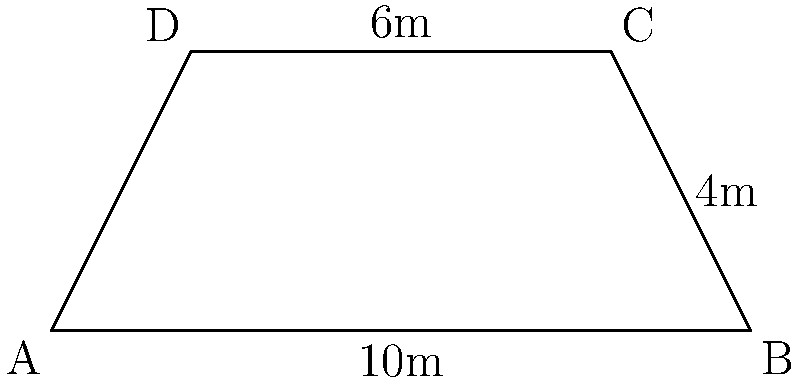Yo, check out this fancy-pants swimming pool at some billionaire's luxury resort! It's shaped like a trapezoid because, you know, regular rectangles are too mainstream for the ultra-rich. The pool's bottom edge is 10m, the top edge is 6m, and the height is 4m. How much water can this bougie oasis hold if it's filled to the brim? (Assume the pool has vertical sides and a flat bottom, 'cause we're keeping it simple for the wealthy folks.) Alright, let's break this down for our laid-back minds:

1) We're dealing with a trapezoid-shaped pool here. The formula for the area of a trapezoid is:

   $$A = \frac{(a+b)h}{2}$$

   Where $a$ and $b$ are the parallel sides, and $h$ is the height.

2) We've got:
   - Bottom edge (a) = 10m
   - Top edge (b) = 6m
   - Height (h) = 4m

3) Let's plug these numbers into our formula:

   $$A = \frac{(10+6) \times 4}{2}$$

4) Simplify the numerator:

   $$A = \frac{16 \times 4}{2}$$

5) Multiply in the numerator:

   $$A = \frac{64}{2}$$

6) And finally, divide:

   $$A = 32$$

So, the area of this luxurious pool is 32 square meters. But remember, we're looking for volume, not area!

7) To get the volume, we multiply the area by the depth. Let's assume the pool is 1.5m deep (because even billionaires don't need Olympic-depth pools for their casual swims):

   $$V = 32 \times 1.5 = 48$$

And there you have it! This swanky trapezoid pool can hold 48 cubic meters of water. That's 48,000 liters of liquid luxury!
Answer: 48 cubic meters 